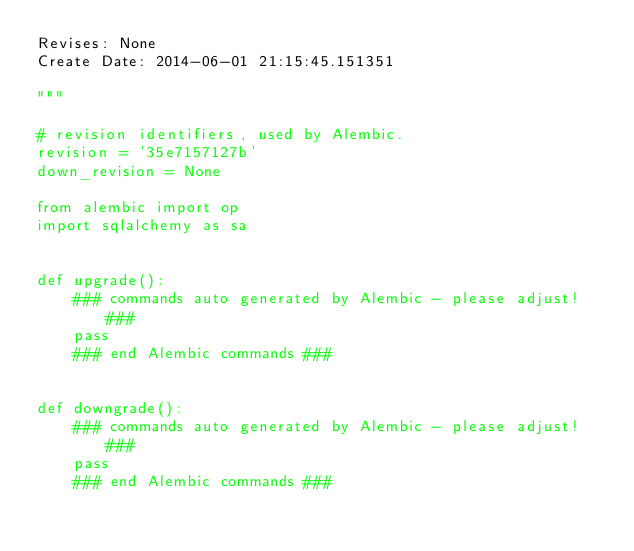Convert code to text. <code><loc_0><loc_0><loc_500><loc_500><_Python_>Revises: None
Create Date: 2014-06-01 21:15:45.151351

"""

# revision identifiers, used by Alembic.
revision = '35e7157127b'
down_revision = None

from alembic import op
import sqlalchemy as sa


def upgrade():
    ### commands auto generated by Alembic - please adjust! ###
    pass
    ### end Alembic commands ###


def downgrade():
    ### commands auto generated by Alembic - please adjust! ###
    pass
    ### end Alembic commands ###
</code> 